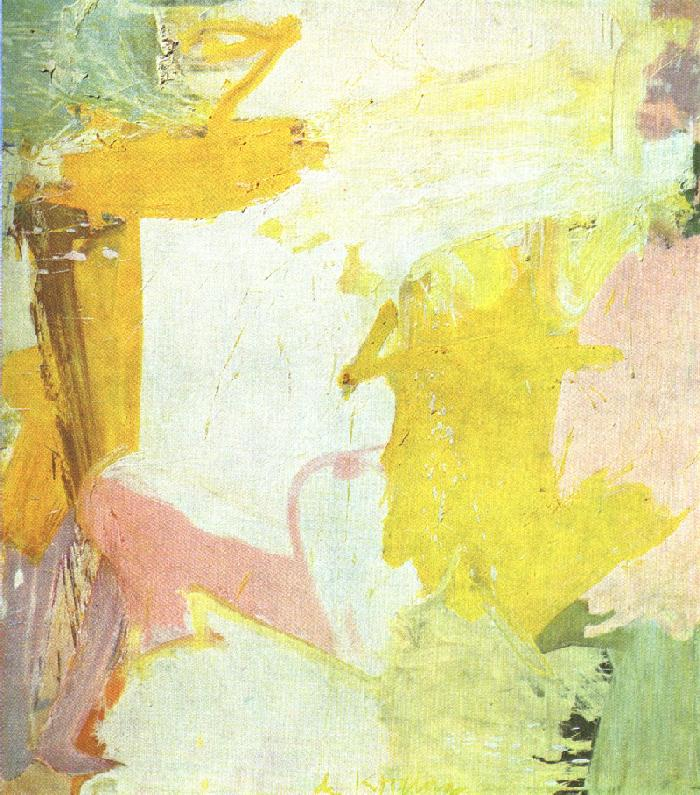Write a detailed description of the given image. The image you've shared is a delightful piece of abstract art characterized by a soft pastel color palette, primarily featuring tones of yellow, pink, and white. Various brushstrokes and textures are used, contributing to the depth and visual interest of the piece. This art style seems to draw inspiration from the post-impressionism movement, focusing more on color and form than on realism. The composition suggests an ethereal, light, and airy mood, with an undercurrent of movement and fluidity. The overall effect is a captivating example of abstract art, capable of evoking diverse emotions and interpretations from different viewers. 